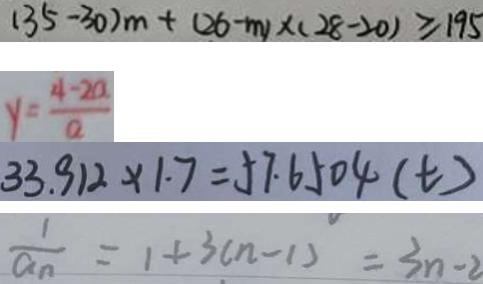Convert formula to latex. <formula><loc_0><loc_0><loc_500><loc_500>( 3 5 - 3 0 ) m + ( 2 6 - m ) \times ( 2 8 - 2 0 ) \geq 1 9 5 
 y = \frac { 4 - 2 a } { a } 
 3 3 . 9 1 2 \times 1 . 7 = 5 7 . 6 5 0 4 ( t ) 
 \frac { 1 } { a _ { n } } = 1 + 3 ( n - 1 ) = 3 n - 2</formula> 